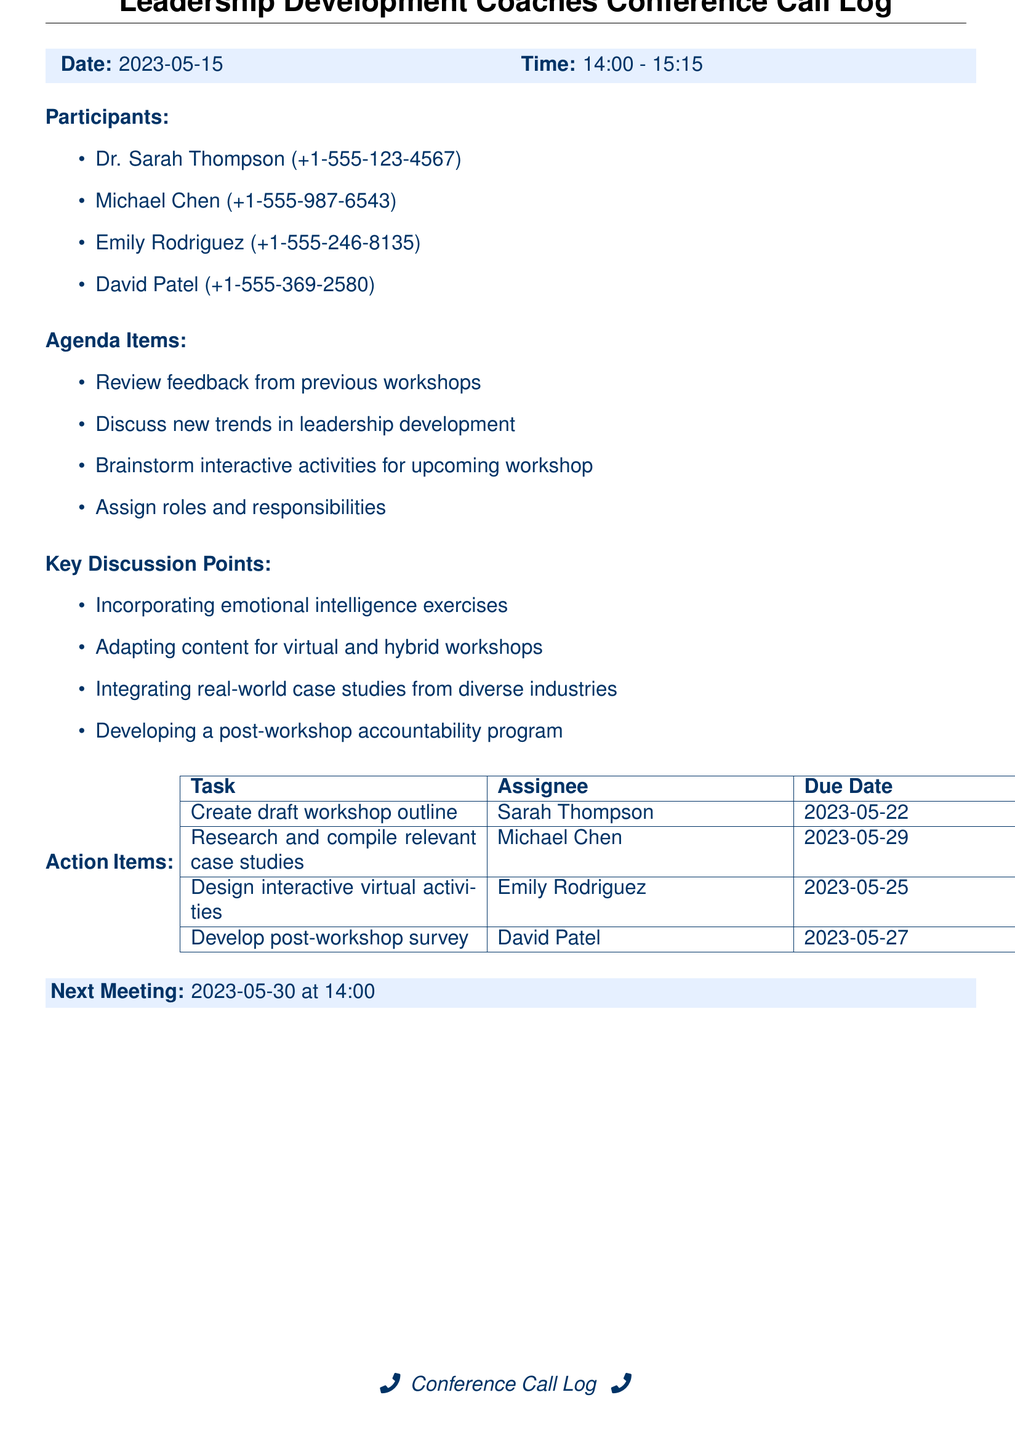What is the date of the conference call? The date is explicitly stated in the document under "Date:".
Answer: 2023-05-15 Who is responsible for creating the draft workshop outline? The action item indicates Sarah Thompson is assigned to this task.
Answer: Sarah Thompson What time did the conference call start? The start time is listed alongside the date in the document.
Answer: 14:00 What is one of the key discussion points mentioned? The document lists several key discussion points, and this is to retrieve one of them.
Answer: Incorporating emotional intelligence exercises When is the next meeting scheduled? The next meeting date is provided in a dedicated section in the document.
Answer: 2023-05-30 How many participants were in the conference call? The number of participants can be counted from the "Participants" list in the document.
Answer: Four What task is assigned to Michael Chen? This refers to the specific task given to Michael Chen listed in the action items.
Answer: Research and compile relevant case studies Which participant is tasked with designing interactive virtual activities? This question looks for the assignee of a specific task mentioned in the action items.
Answer: Emily Rodriguez What was one of the agenda items discussed? The agenda items are listed, and this question seeks one of those items.
Answer: Discuss new trends in leadership development 